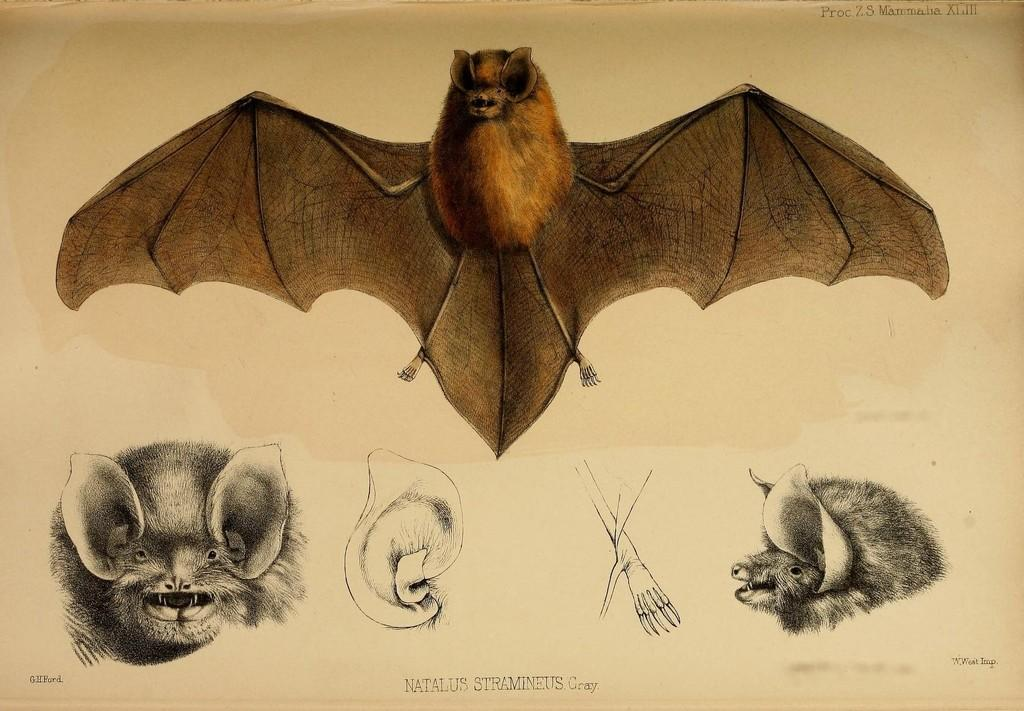What is present on the paper in the image? The paper contains drawings and text. What are the drawings of? The drawings depict animals. Can you describe the text on the paper? Unfortunately, the specific content of the text cannot be determined from the image. What level of respect is shown by the animals in the drawings? The image does not provide any information about the level of respect shown by the animals in the drawings. 